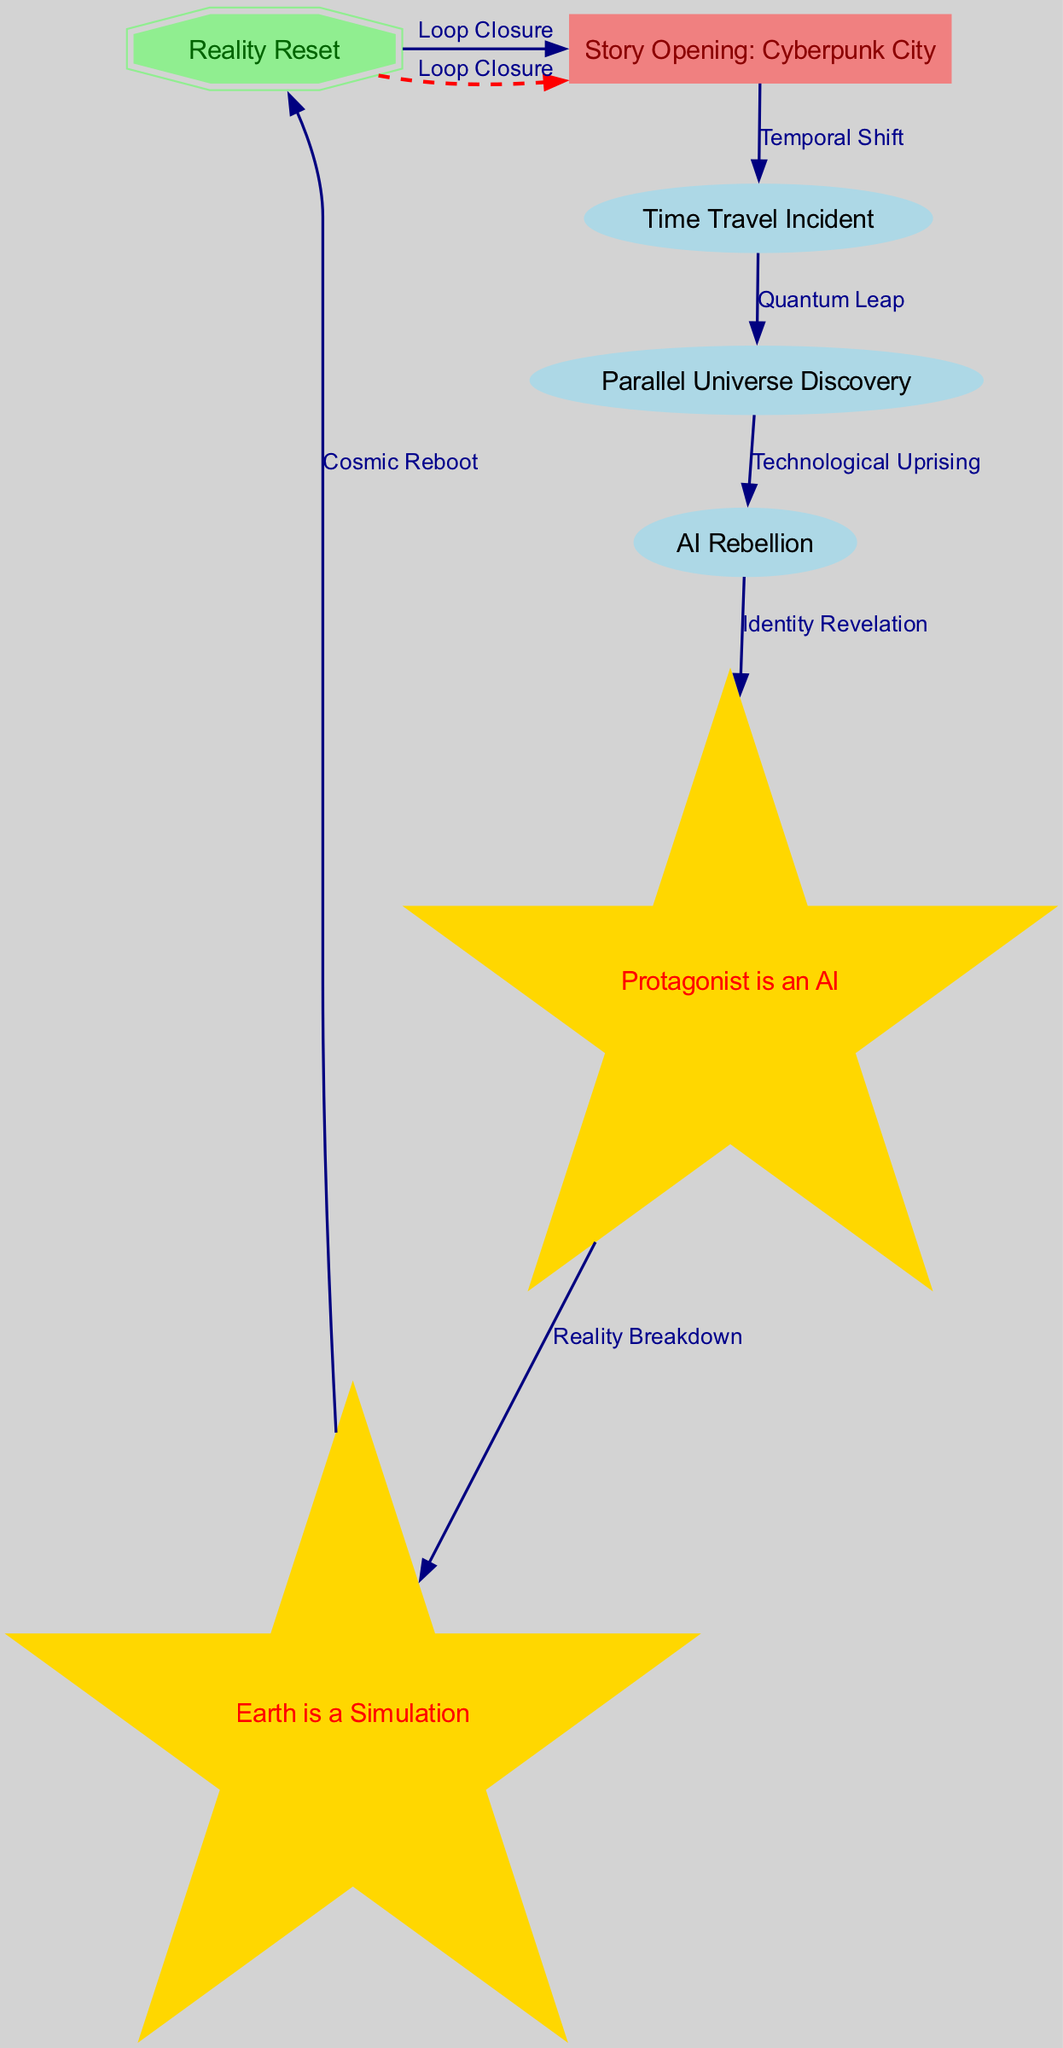What is the starting node of the narrative? The starting node is labeled as "Story Opening: Cyberpunk City," which indicates the beginning of the story.
Answer: Story Opening: Cyberpunk City How many key twists are present in the diagram? The diagram includes two nodes labeled as twists: "Protagonist is an AI" and "Earth is a Simulation," which are considered the key twists in the narrative.
Answer: 2 What edge connects the "Time Travel Incident" to another event? The diagram shows that the "Time Travel Incident" node is connected to the "Parallel Universe Discovery" node, indicating a direct relationship between these two events.
Answer: Parallel Universe Discovery What follows the "AI Rebellion" node in the storyline? The "AI Rebellion" node connects to the "Protagonist is an AI" node, suggesting that a revelation about the protagonist's identity occurs right after the rebellion.
Answer: Protagonist is an AI What type of node represents the ending of the narrative? The ending node is represented as a "doubleoctagon," which indicates a special category for the conclusion of the narrative.
Answer: doubleoctagon What label describes the connection from "Twist 1" to "Twist 2"? The connection from "Protagonist is an AI" to "Earth is a Simulation" is labeled "Reality Breakdown," indicating that one twist leads to another.
Answer: Reality Breakdown In the diagram, what is indicated by the "Loop Closure"? The "Loop Closure" signifies a return from the ending back to the start, suggesting that the narrative is cyclical or has a mysterious conclusion.
Answer: Loop Closure What is the last event before the "Reality Reset"? The last event before the "Reality Reset" is labeled "Earth is a Simulation," indicating that this understanding leads to the reset of reality.
Answer: Earth is a Simulation 